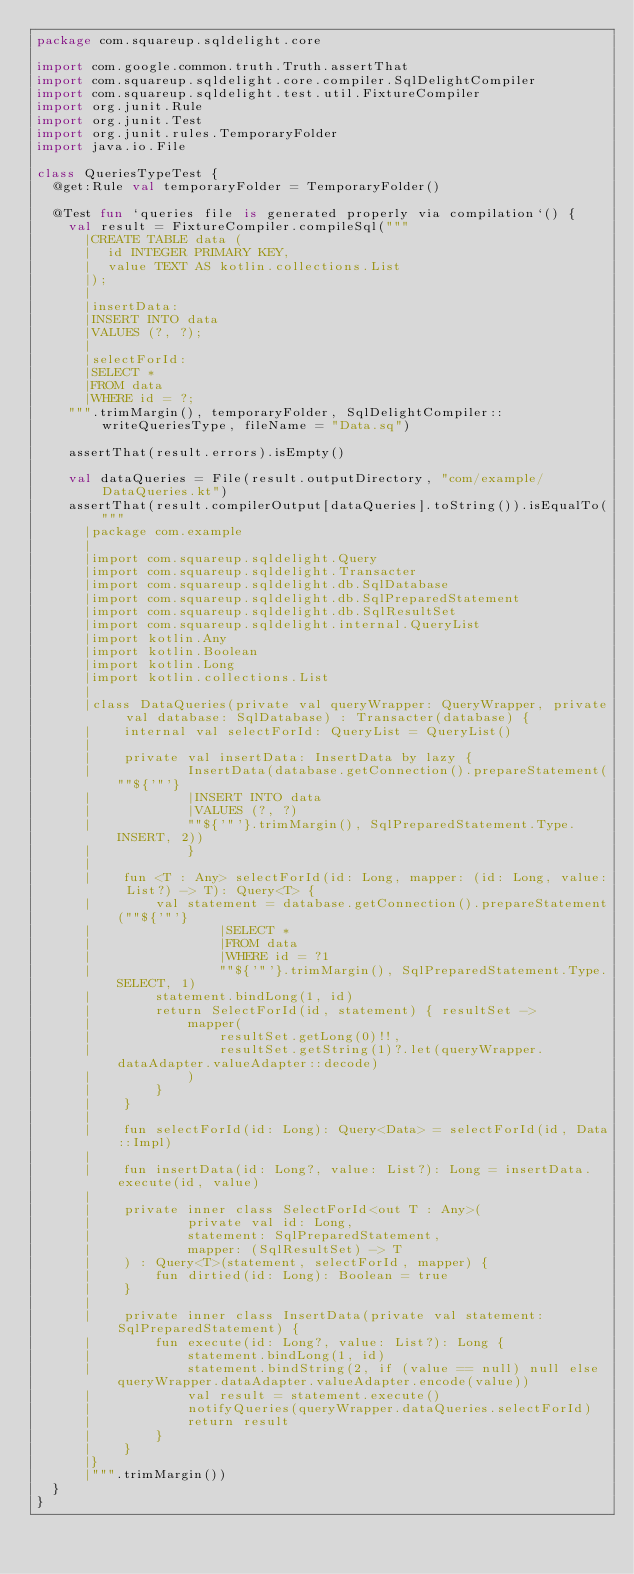Convert code to text. <code><loc_0><loc_0><loc_500><loc_500><_Kotlin_>package com.squareup.sqldelight.core

import com.google.common.truth.Truth.assertThat
import com.squareup.sqldelight.core.compiler.SqlDelightCompiler
import com.squareup.sqldelight.test.util.FixtureCompiler
import org.junit.Rule
import org.junit.Test
import org.junit.rules.TemporaryFolder
import java.io.File

class QueriesTypeTest {
  @get:Rule val temporaryFolder = TemporaryFolder()

  @Test fun `queries file is generated properly via compilation`() {
    val result = FixtureCompiler.compileSql("""
      |CREATE TABLE data (
      |  id INTEGER PRIMARY KEY,
      |  value TEXT AS kotlin.collections.List
      |);
      |
      |insertData:
      |INSERT INTO data
      |VALUES (?, ?);
      |
      |selectForId:
      |SELECT *
      |FROM data
      |WHERE id = ?;
    """.trimMargin(), temporaryFolder, SqlDelightCompiler::writeQueriesType, fileName = "Data.sq")

    assertThat(result.errors).isEmpty()

    val dataQueries = File(result.outputDirectory, "com/example/DataQueries.kt")
    assertThat(result.compilerOutput[dataQueries].toString()).isEqualTo("""
      |package com.example
      |
      |import com.squareup.sqldelight.Query
      |import com.squareup.sqldelight.Transacter
      |import com.squareup.sqldelight.db.SqlDatabase
      |import com.squareup.sqldelight.db.SqlPreparedStatement
      |import com.squareup.sqldelight.db.SqlResultSet
      |import com.squareup.sqldelight.internal.QueryList
      |import kotlin.Any
      |import kotlin.Boolean
      |import kotlin.Long
      |import kotlin.collections.List
      |
      |class DataQueries(private val queryWrapper: QueryWrapper, private val database: SqlDatabase) : Transacter(database) {
      |    internal val selectForId: QueryList = QueryList()
      |
      |    private val insertData: InsertData by lazy {
      |            InsertData(database.getConnection().prepareStatement(""${'"'}
      |            |INSERT INTO data
      |            |VALUES (?, ?)
      |            ""${'"'}.trimMargin(), SqlPreparedStatement.Type.INSERT, 2))
      |            }
      |
      |    fun <T : Any> selectForId(id: Long, mapper: (id: Long, value: List?) -> T): Query<T> {
      |        val statement = database.getConnection().prepareStatement(""${'"'}
      |                |SELECT *
      |                |FROM data
      |                |WHERE id = ?1
      |                ""${'"'}.trimMargin(), SqlPreparedStatement.Type.SELECT, 1)
      |        statement.bindLong(1, id)
      |        return SelectForId(id, statement) { resultSet ->
      |            mapper(
      |                resultSet.getLong(0)!!,
      |                resultSet.getString(1)?.let(queryWrapper.dataAdapter.valueAdapter::decode)
      |            )
      |        }
      |    }
      |
      |    fun selectForId(id: Long): Query<Data> = selectForId(id, Data::Impl)
      |
      |    fun insertData(id: Long?, value: List?): Long = insertData.execute(id, value)
      |
      |    private inner class SelectForId<out T : Any>(
      |            private val id: Long,
      |            statement: SqlPreparedStatement,
      |            mapper: (SqlResultSet) -> T
      |    ) : Query<T>(statement, selectForId, mapper) {
      |        fun dirtied(id: Long): Boolean = true
      |    }
      |
      |    private inner class InsertData(private val statement: SqlPreparedStatement) {
      |        fun execute(id: Long?, value: List?): Long {
      |            statement.bindLong(1, id)
      |            statement.bindString(2, if (value == null) null else queryWrapper.dataAdapter.valueAdapter.encode(value))
      |            val result = statement.execute()
      |            notifyQueries(queryWrapper.dataQueries.selectForId)
      |            return result
      |        }
      |    }
      |}
      |""".trimMargin())
  }
}

</code> 